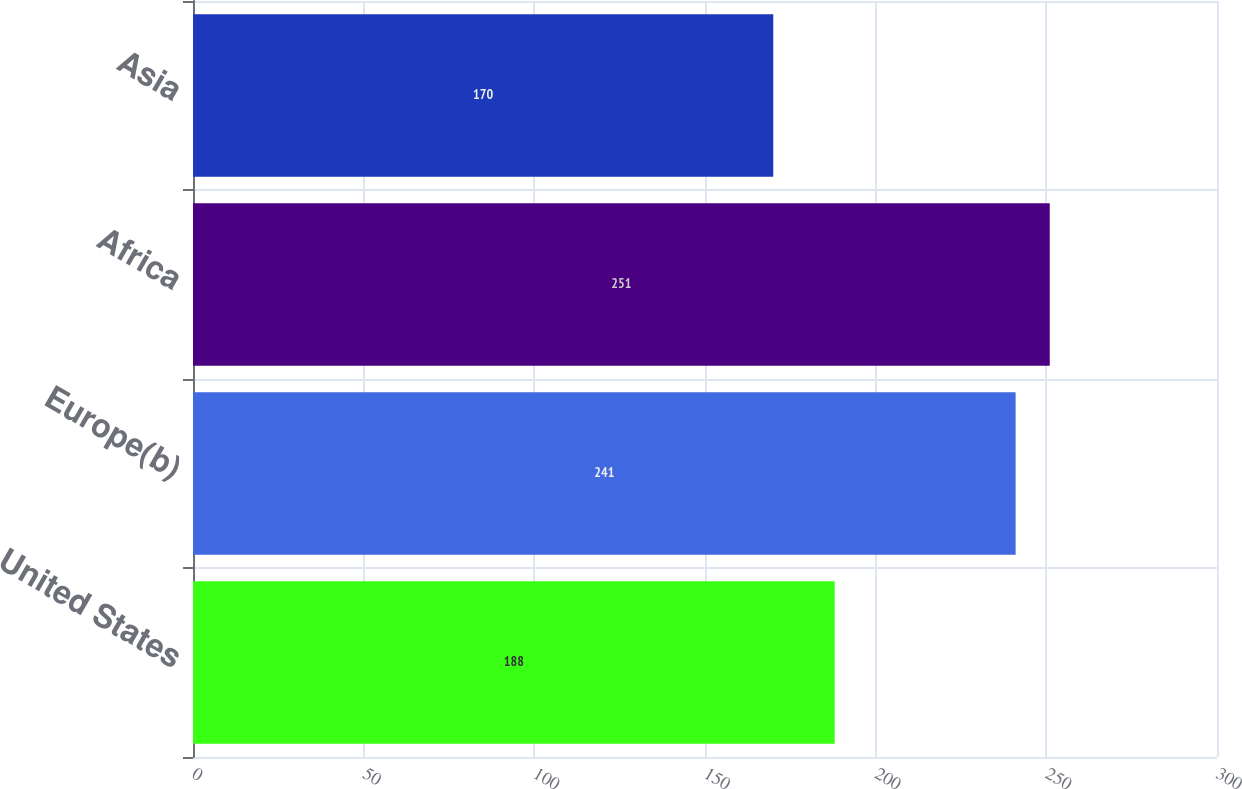<chart> <loc_0><loc_0><loc_500><loc_500><bar_chart><fcel>United States<fcel>Europe(b)<fcel>Africa<fcel>Asia<nl><fcel>188<fcel>241<fcel>251<fcel>170<nl></chart> 